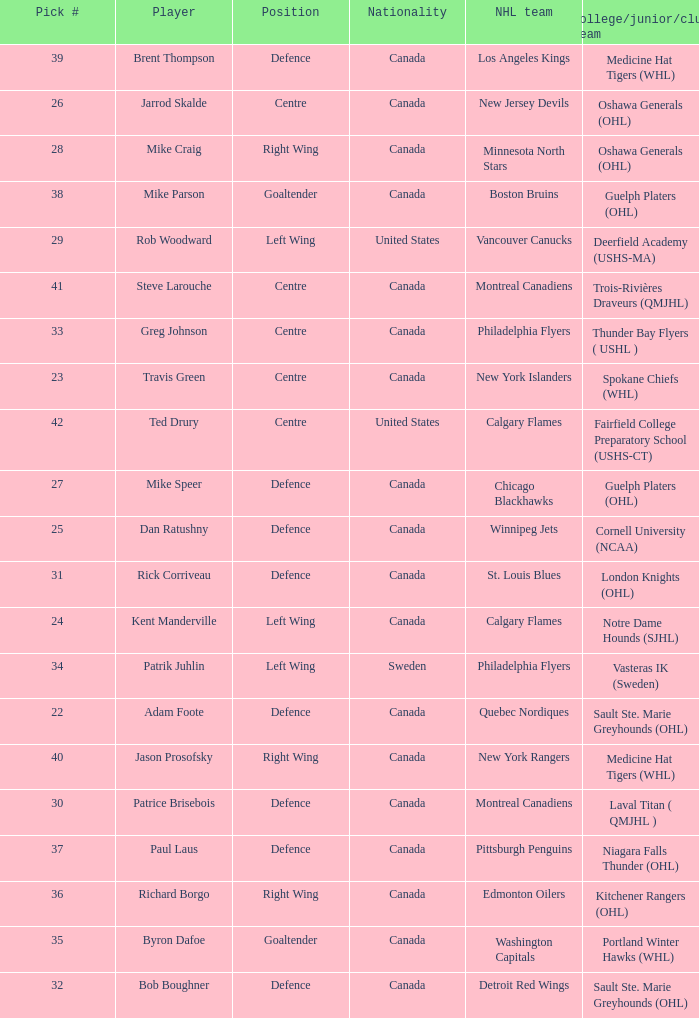What player came from Cornell University (NCAA)? Dan Ratushny. 